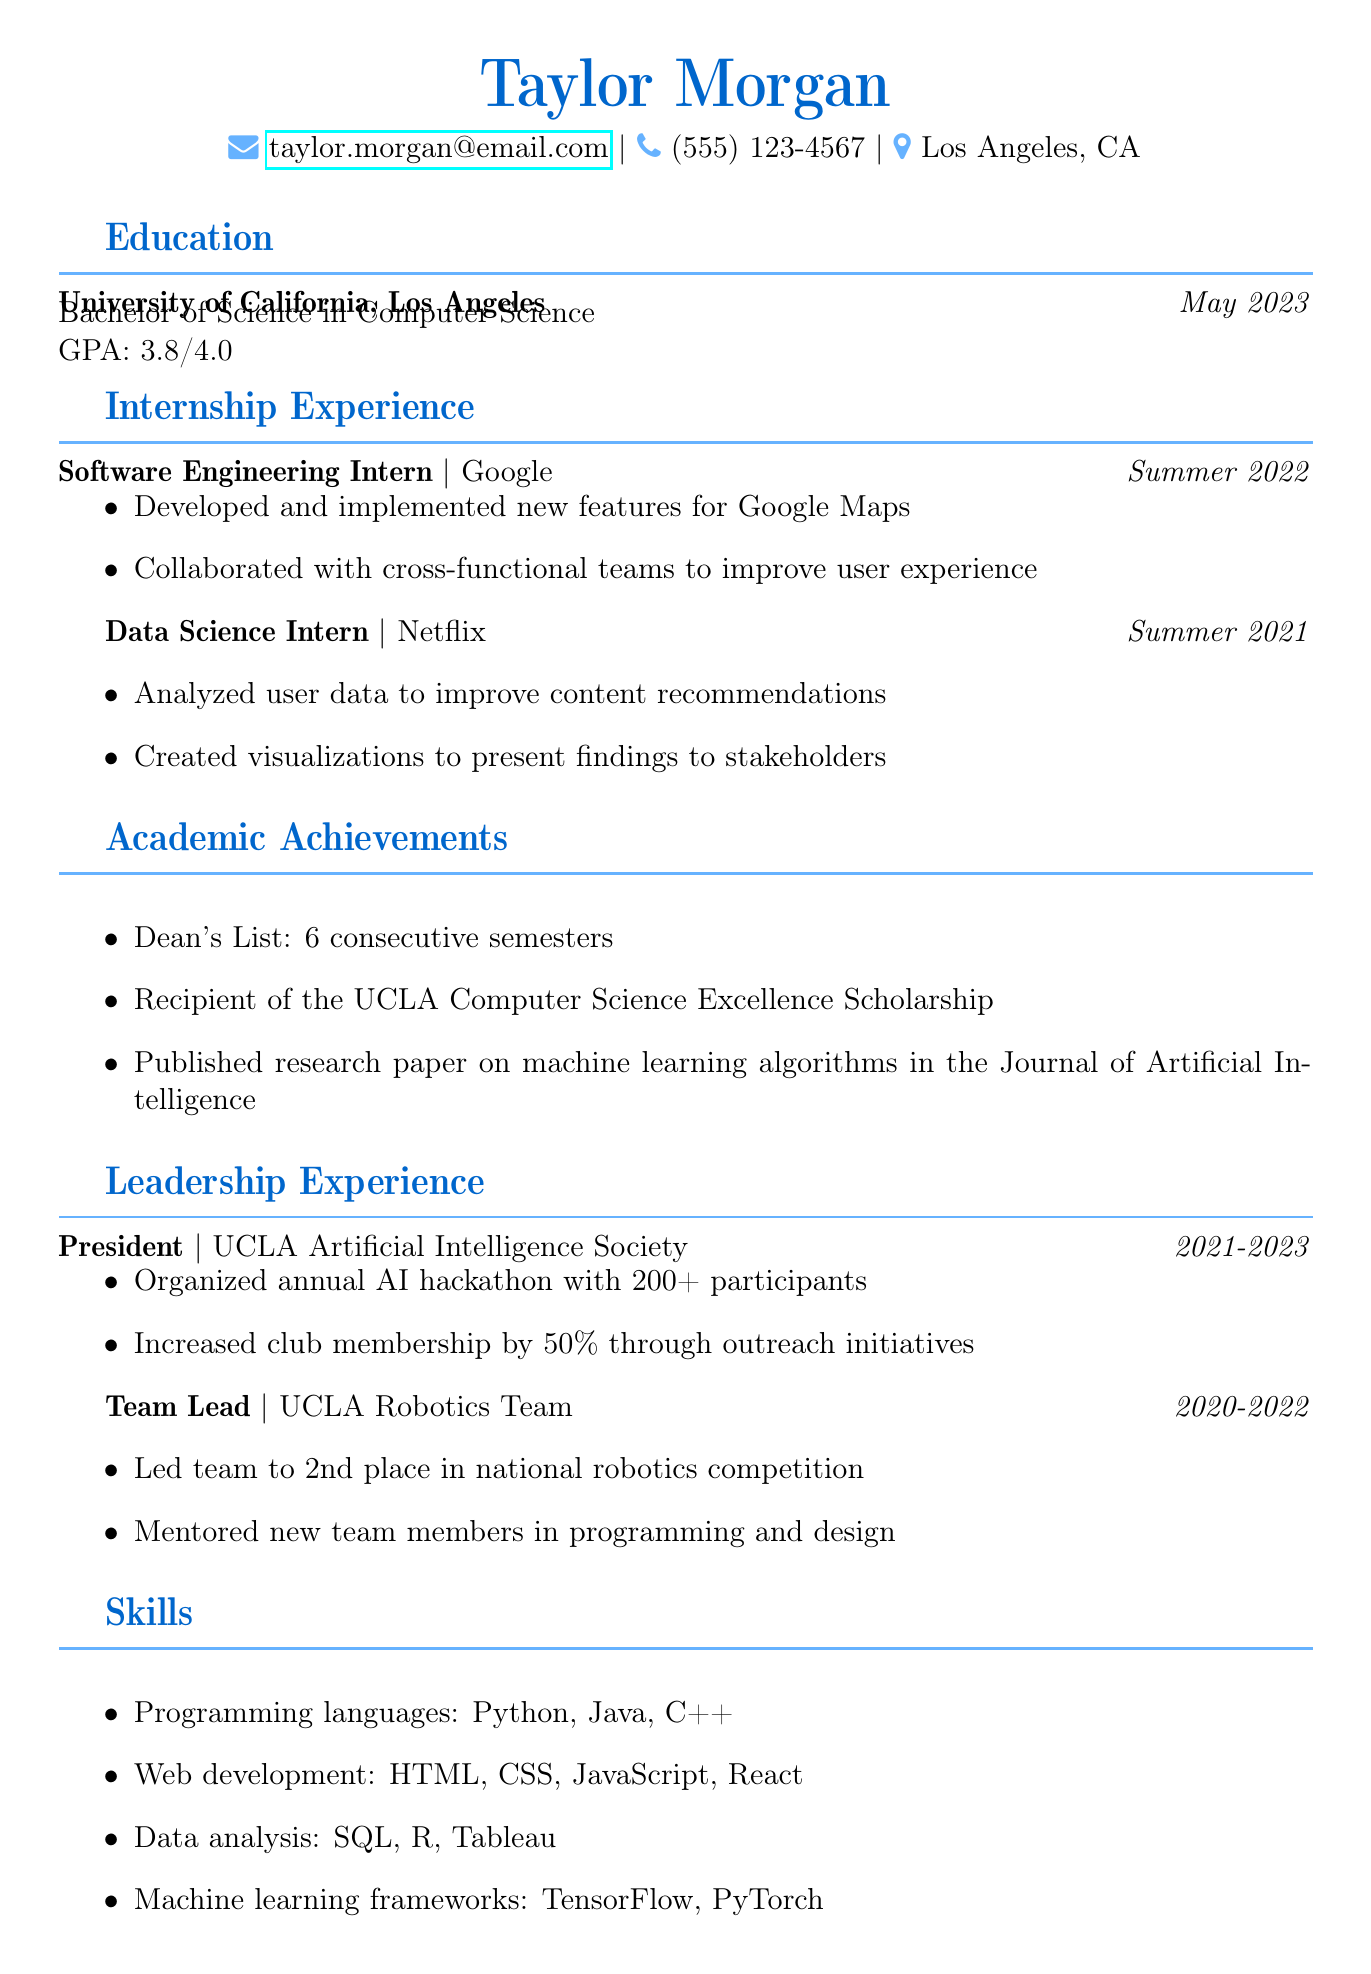What is the name of the graduate? The name of the graduate is stated at the top of the document.
Answer: Taylor Morgan What is Taylor Morgan's degree? The degree obtained by Taylor Morgan is mentioned in the education section of the document.
Answer: Bachelor of Science in Computer Science What is the GPA of Taylor Morgan? The GPA is listed directly under the education section.
Answer: 3.8/4.0 Which company did Taylor Morgan intern with in the summer of 2022? The document specifies the company where Taylor Morgan completed the internship during that summer.
Answer: Google What was one responsibility of the Data Science Intern at Netflix? This information can be found under the internship experience regarding the specific responsibilities of that role.
Answer: Analyzed user data to improve content recommendations How many consecutive semesters was Taylor on the Dean's List? The document lists the number of semesters in the academic achievements section.
Answer: 6 What leadership role did Taylor hold in the UCLA Artificial Intelligence Society? This information is referenced in the leadership experience section of the document.
Answer: President What significant event did Taylor organize as the President of the UCLA Artificial Intelligence Society? This detail is mentioned under the achievements section for the leadership role.
Answer: Annual AI hackathon How many participants were involved in the annual AI hackathon? The document quantifies the event's size in the achievements for the leadership role.
Answer: 200+ 